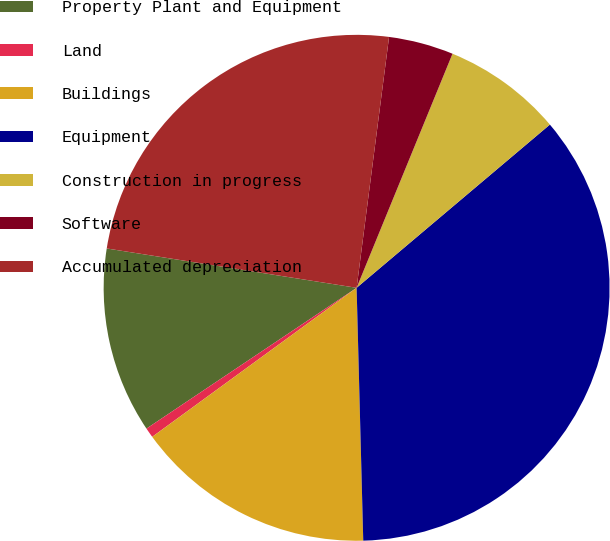Convert chart. <chart><loc_0><loc_0><loc_500><loc_500><pie_chart><fcel>Property Plant and Equipment<fcel>Land<fcel>Buildings<fcel>Equipment<fcel>Construction in progress<fcel>Software<fcel>Accumulated depreciation<nl><fcel>11.88%<fcel>0.63%<fcel>15.39%<fcel>35.74%<fcel>7.65%<fcel>4.14%<fcel>24.56%<nl></chart> 